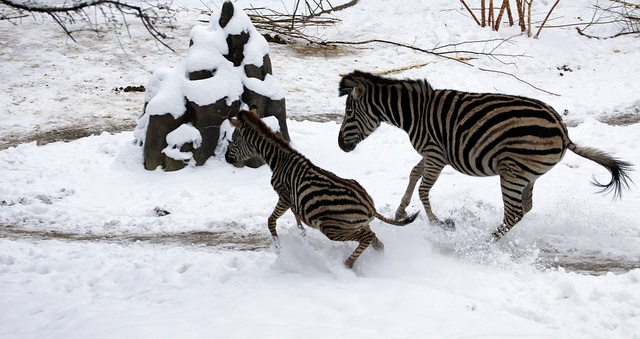Describe the objects in this image and their specific colors. I can see zebra in black and gray tones and zebra in black and gray tones in this image. 